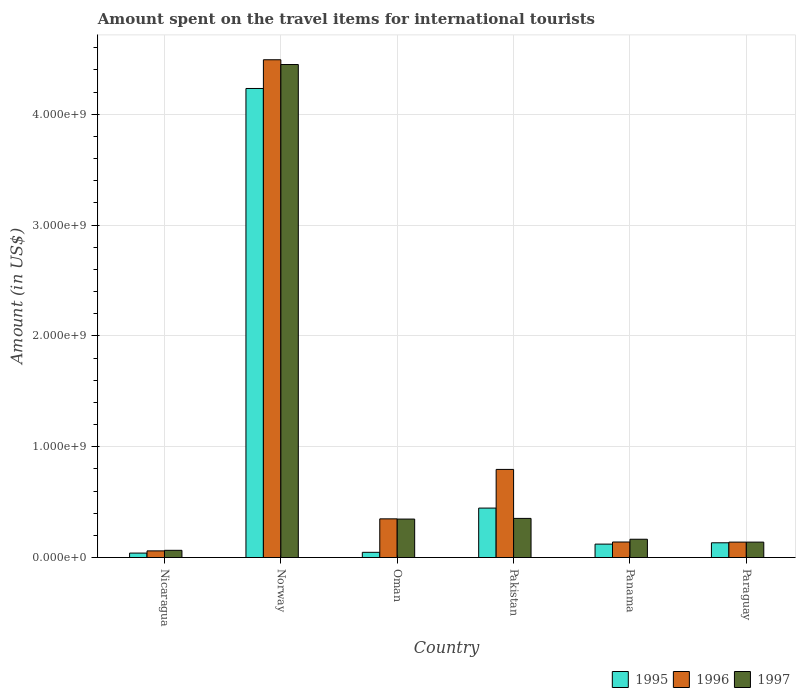How many different coloured bars are there?
Your answer should be very brief. 3. How many groups of bars are there?
Your response must be concise. 6. Are the number of bars per tick equal to the number of legend labels?
Ensure brevity in your answer.  Yes. How many bars are there on the 1st tick from the left?
Your answer should be compact. 3. How many bars are there on the 3rd tick from the right?
Your answer should be compact. 3. What is the amount spent on the travel items for international tourists in 1995 in Oman?
Keep it short and to the point. 4.70e+07. Across all countries, what is the maximum amount spent on the travel items for international tourists in 1996?
Keep it short and to the point. 4.49e+09. Across all countries, what is the minimum amount spent on the travel items for international tourists in 1995?
Offer a terse response. 4.00e+07. In which country was the amount spent on the travel items for international tourists in 1996 minimum?
Give a very brief answer. Nicaragua. What is the total amount spent on the travel items for international tourists in 1996 in the graph?
Offer a terse response. 5.97e+09. What is the difference between the amount spent on the travel items for international tourists in 1997 in Panama and that in Paraguay?
Ensure brevity in your answer.  2.60e+07. What is the difference between the amount spent on the travel items for international tourists in 1996 in Oman and the amount spent on the travel items for international tourists in 1995 in Nicaragua?
Provide a short and direct response. 3.09e+08. What is the average amount spent on the travel items for international tourists in 1995 per country?
Your response must be concise. 8.36e+08. What is the difference between the amount spent on the travel items for international tourists of/in 1995 and amount spent on the travel items for international tourists of/in 1996 in Panama?
Your answer should be very brief. -1.90e+07. In how many countries, is the amount spent on the travel items for international tourists in 1997 greater than 1400000000 US$?
Give a very brief answer. 1. What is the ratio of the amount spent on the travel items for international tourists in 1995 in Norway to that in Oman?
Give a very brief answer. 90.04. Is the difference between the amount spent on the travel items for international tourists in 1995 in Pakistan and Panama greater than the difference between the amount spent on the travel items for international tourists in 1996 in Pakistan and Panama?
Make the answer very short. No. What is the difference between the highest and the second highest amount spent on the travel items for international tourists in 1995?
Give a very brief answer. 4.10e+09. What is the difference between the highest and the lowest amount spent on the travel items for international tourists in 1996?
Offer a very short reply. 4.43e+09. In how many countries, is the amount spent on the travel items for international tourists in 1996 greater than the average amount spent on the travel items for international tourists in 1996 taken over all countries?
Make the answer very short. 1. Is the sum of the amount spent on the travel items for international tourists in 1997 in Oman and Pakistan greater than the maximum amount spent on the travel items for international tourists in 1995 across all countries?
Ensure brevity in your answer.  No. What does the 3rd bar from the right in Panama represents?
Offer a terse response. 1995. Is it the case that in every country, the sum of the amount spent on the travel items for international tourists in 1996 and amount spent on the travel items for international tourists in 1997 is greater than the amount spent on the travel items for international tourists in 1995?
Provide a short and direct response. Yes. How many countries are there in the graph?
Offer a terse response. 6. What is the difference between two consecutive major ticks on the Y-axis?
Give a very brief answer. 1.00e+09. Does the graph contain any zero values?
Your answer should be very brief. No. Where does the legend appear in the graph?
Offer a terse response. Bottom right. What is the title of the graph?
Your response must be concise. Amount spent on the travel items for international tourists. What is the label or title of the X-axis?
Provide a succinct answer. Country. What is the Amount (in US$) of 1995 in Nicaragua?
Provide a short and direct response. 4.00e+07. What is the Amount (in US$) in 1996 in Nicaragua?
Keep it short and to the point. 6.00e+07. What is the Amount (in US$) in 1997 in Nicaragua?
Provide a succinct answer. 6.50e+07. What is the Amount (in US$) of 1995 in Norway?
Give a very brief answer. 4.23e+09. What is the Amount (in US$) in 1996 in Norway?
Provide a succinct answer. 4.49e+09. What is the Amount (in US$) of 1997 in Norway?
Your answer should be very brief. 4.45e+09. What is the Amount (in US$) in 1995 in Oman?
Ensure brevity in your answer.  4.70e+07. What is the Amount (in US$) in 1996 in Oman?
Provide a short and direct response. 3.49e+08. What is the Amount (in US$) of 1997 in Oman?
Offer a very short reply. 3.47e+08. What is the Amount (in US$) of 1995 in Pakistan?
Ensure brevity in your answer.  4.46e+08. What is the Amount (in US$) of 1996 in Pakistan?
Your response must be concise. 7.95e+08. What is the Amount (in US$) of 1997 in Pakistan?
Provide a short and direct response. 3.53e+08. What is the Amount (in US$) of 1995 in Panama?
Your answer should be very brief. 1.21e+08. What is the Amount (in US$) of 1996 in Panama?
Make the answer very short. 1.40e+08. What is the Amount (in US$) in 1997 in Panama?
Keep it short and to the point. 1.65e+08. What is the Amount (in US$) in 1995 in Paraguay?
Provide a succinct answer. 1.33e+08. What is the Amount (in US$) in 1996 in Paraguay?
Provide a succinct answer. 1.39e+08. What is the Amount (in US$) of 1997 in Paraguay?
Your answer should be compact. 1.39e+08. Across all countries, what is the maximum Amount (in US$) of 1995?
Provide a succinct answer. 4.23e+09. Across all countries, what is the maximum Amount (in US$) in 1996?
Give a very brief answer. 4.49e+09. Across all countries, what is the maximum Amount (in US$) in 1997?
Provide a succinct answer. 4.45e+09. Across all countries, what is the minimum Amount (in US$) in 1995?
Your answer should be compact. 4.00e+07. Across all countries, what is the minimum Amount (in US$) of 1996?
Give a very brief answer. 6.00e+07. Across all countries, what is the minimum Amount (in US$) in 1997?
Ensure brevity in your answer.  6.50e+07. What is the total Amount (in US$) of 1995 in the graph?
Give a very brief answer. 5.02e+09. What is the total Amount (in US$) in 1996 in the graph?
Your answer should be very brief. 5.97e+09. What is the total Amount (in US$) in 1997 in the graph?
Give a very brief answer. 5.52e+09. What is the difference between the Amount (in US$) in 1995 in Nicaragua and that in Norway?
Your response must be concise. -4.19e+09. What is the difference between the Amount (in US$) of 1996 in Nicaragua and that in Norway?
Provide a succinct answer. -4.43e+09. What is the difference between the Amount (in US$) in 1997 in Nicaragua and that in Norway?
Your response must be concise. -4.38e+09. What is the difference between the Amount (in US$) in 1995 in Nicaragua and that in Oman?
Offer a terse response. -7.00e+06. What is the difference between the Amount (in US$) in 1996 in Nicaragua and that in Oman?
Offer a very short reply. -2.89e+08. What is the difference between the Amount (in US$) of 1997 in Nicaragua and that in Oman?
Your answer should be compact. -2.82e+08. What is the difference between the Amount (in US$) of 1995 in Nicaragua and that in Pakistan?
Offer a terse response. -4.06e+08. What is the difference between the Amount (in US$) of 1996 in Nicaragua and that in Pakistan?
Offer a terse response. -7.35e+08. What is the difference between the Amount (in US$) in 1997 in Nicaragua and that in Pakistan?
Give a very brief answer. -2.88e+08. What is the difference between the Amount (in US$) in 1995 in Nicaragua and that in Panama?
Your answer should be compact. -8.10e+07. What is the difference between the Amount (in US$) in 1996 in Nicaragua and that in Panama?
Provide a succinct answer. -8.00e+07. What is the difference between the Amount (in US$) in 1997 in Nicaragua and that in Panama?
Offer a very short reply. -1.00e+08. What is the difference between the Amount (in US$) of 1995 in Nicaragua and that in Paraguay?
Give a very brief answer. -9.30e+07. What is the difference between the Amount (in US$) of 1996 in Nicaragua and that in Paraguay?
Make the answer very short. -7.90e+07. What is the difference between the Amount (in US$) of 1997 in Nicaragua and that in Paraguay?
Provide a succinct answer. -7.40e+07. What is the difference between the Amount (in US$) in 1995 in Norway and that in Oman?
Offer a very short reply. 4.18e+09. What is the difference between the Amount (in US$) of 1996 in Norway and that in Oman?
Make the answer very short. 4.14e+09. What is the difference between the Amount (in US$) of 1997 in Norway and that in Oman?
Make the answer very short. 4.10e+09. What is the difference between the Amount (in US$) in 1995 in Norway and that in Pakistan?
Your answer should be very brief. 3.79e+09. What is the difference between the Amount (in US$) in 1996 in Norway and that in Pakistan?
Offer a very short reply. 3.70e+09. What is the difference between the Amount (in US$) of 1997 in Norway and that in Pakistan?
Offer a terse response. 4.10e+09. What is the difference between the Amount (in US$) in 1995 in Norway and that in Panama?
Keep it short and to the point. 4.11e+09. What is the difference between the Amount (in US$) of 1996 in Norway and that in Panama?
Offer a very short reply. 4.35e+09. What is the difference between the Amount (in US$) of 1997 in Norway and that in Panama?
Offer a terse response. 4.28e+09. What is the difference between the Amount (in US$) in 1995 in Norway and that in Paraguay?
Offer a very short reply. 4.10e+09. What is the difference between the Amount (in US$) in 1996 in Norway and that in Paraguay?
Give a very brief answer. 4.35e+09. What is the difference between the Amount (in US$) of 1997 in Norway and that in Paraguay?
Give a very brief answer. 4.31e+09. What is the difference between the Amount (in US$) of 1995 in Oman and that in Pakistan?
Provide a succinct answer. -3.99e+08. What is the difference between the Amount (in US$) of 1996 in Oman and that in Pakistan?
Your answer should be compact. -4.46e+08. What is the difference between the Amount (in US$) in 1997 in Oman and that in Pakistan?
Offer a very short reply. -6.00e+06. What is the difference between the Amount (in US$) of 1995 in Oman and that in Panama?
Keep it short and to the point. -7.40e+07. What is the difference between the Amount (in US$) of 1996 in Oman and that in Panama?
Provide a succinct answer. 2.09e+08. What is the difference between the Amount (in US$) in 1997 in Oman and that in Panama?
Ensure brevity in your answer.  1.82e+08. What is the difference between the Amount (in US$) in 1995 in Oman and that in Paraguay?
Offer a terse response. -8.60e+07. What is the difference between the Amount (in US$) of 1996 in Oman and that in Paraguay?
Make the answer very short. 2.10e+08. What is the difference between the Amount (in US$) of 1997 in Oman and that in Paraguay?
Your answer should be very brief. 2.08e+08. What is the difference between the Amount (in US$) in 1995 in Pakistan and that in Panama?
Offer a terse response. 3.25e+08. What is the difference between the Amount (in US$) of 1996 in Pakistan and that in Panama?
Your response must be concise. 6.55e+08. What is the difference between the Amount (in US$) of 1997 in Pakistan and that in Panama?
Provide a succinct answer. 1.88e+08. What is the difference between the Amount (in US$) in 1995 in Pakistan and that in Paraguay?
Your answer should be very brief. 3.13e+08. What is the difference between the Amount (in US$) of 1996 in Pakistan and that in Paraguay?
Provide a succinct answer. 6.56e+08. What is the difference between the Amount (in US$) of 1997 in Pakistan and that in Paraguay?
Your response must be concise. 2.14e+08. What is the difference between the Amount (in US$) of 1995 in Panama and that in Paraguay?
Your answer should be compact. -1.20e+07. What is the difference between the Amount (in US$) of 1997 in Panama and that in Paraguay?
Make the answer very short. 2.60e+07. What is the difference between the Amount (in US$) in 1995 in Nicaragua and the Amount (in US$) in 1996 in Norway?
Your response must be concise. -4.45e+09. What is the difference between the Amount (in US$) in 1995 in Nicaragua and the Amount (in US$) in 1997 in Norway?
Your response must be concise. -4.41e+09. What is the difference between the Amount (in US$) in 1996 in Nicaragua and the Amount (in US$) in 1997 in Norway?
Your answer should be compact. -4.39e+09. What is the difference between the Amount (in US$) in 1995 in Nicaragua and the Amount (in US$) in 1996 in Oman?
Offer a terse response. -3.09e+08. What is the difference between the Amount (in US$) of 1995 in Nicaragua and the Amount (in US$) of 1997 in Oman?
Provide a short and direct response. -3.07e+08. What is the difference between the Amount (in US$) in 1996 in Nicaragua and the Amount (in US$) in 1997 in Oman?
Provide a short and direct response. -2.87e+08. What is the difference between the Amount (in US$) in 1995 in Nicaragua and the Amount (in US$) in 1996 in Pakistan?
Provide a succinct answer. -7.55e+08. What is the difference between the Amount (in US$) in 1995 in Nicaragua and the Amount (in US$) in 1997 in Pakistan?
Your answer should be very brief. -3.13e+08. What is the difference between the Amount (in US$) of 1996 in Nicaragua and the Amount (in US$) of 1997 in Pakistan?
Keep it short and to the point. -2.93e+08. What is the difference between the Amount (in US$) of 1995 in Nicaragua and the Amount (in US$) of 1996 in Panama?
Keep it short and to the point. -1.00e+08. What is the difference between the Amount (in US$) of 1995 in Nicaragua and the Amount (in US$) of 1997 in Panama?
Provide a succinct answer. -1.25e+08. What is the difference between the Amount (in US$) of 1996 in Nicaragua and the Amount (in US$) of 1997 in Panama?
Your answer should be compact. -1.05e+08. What is the difference between the Amount (in US$) in 1995 in Nicaragua and the Amount (in US$) in 1996 in Paraguay?
Offer a terse response. -9.90e+07. What is the difference between the Amount (in US$) of 1995 in Nicaragua and the Amount (in US$) of 1997 in Paraguay?
Provide a short and direct response. -9.90e+07. What is the difference between the Amount (in US$) of 1996 in Nicaragua and the Amount (in US$) of 1997 in Paraguay?
Provide a short and direct response. -7.90e+07. What is the difference between the Amount (in US$) of 1995 in Norway and the Amount (in US$) of 1996 in Oman?
Your answer should be compact. 3.88e+09. What is the difference between the Amount (in US$) in 1995 in Norway and the Amount (in US$) in 1997 in Oman?
Keep it short and to the point. 3.88e+09. What is the difference between the Amount (in US$) of 1996 in Norway and the Amount (in US$) of 1997 in Oman?
Give a very brief answer. 4.14e+09. What is the difference between the Amount (in US$) of 1995 in Norway and the Amount (in US$) of 1996 in Pakistan?
Provide a short and direct response. 3.44e+09. What is the difference between the Amount (in US$) in 1995 in Norway and the Amount (in US$) in 1997 in Pakistan?
Your response must be concise. 3.88e+09. What is the difference between the Amount (in US$) of 1996 in Norway and the Amount (in US$) of 1997 in Pakistan?
Ensure brevity in your answer.  4.14e+09. What is the difference between the Amount (in US$) of 1995 in Norway and the Amount (in US$) of 1996 in Panama?
Keep it short and to the point. 4.09e+09. What is the difference between the Amount (in US$) of 1995 in Norway and the Amount (in US$) of 1997 in Panama?
Your answer should be very brief. 4.07e+09. What is the difference between the Amount (in US$) in 1996 in Norway and the Amount (in US$) in 1997 in Panama?
Your response must be concise. 4.33e+09. What is the difference between the Amount (in US$) in 1995 in Norway and the Amount (in US$) in 1996 in Paraguay?
Give a very brief answer. 4.09e+09. What is the difference between the Amount (in US$) in 1995 in Norway and the Amount (in US$) in 1997 in Paraguay?
Keep it short and to the point. 4.09e+09. What is the difference between the Amount (in US$) of 1996 in Norway and the Amount (in US$) of 1997 in Paraguay?
Make the answer very short. 4.35e+09. What is the difference between the Amount (in US$) of 1995 in Oman and the Amount (in US$) of 1996 in Pakistan?
Your answer should be very brief. -7.48e+08. What is the difference between the Amount (in US$) of 1995 in Oman and the Amount (in US$) of 1997 in Pakistan?
Offer a terse response. -3.06e+08. What is the difference between the Amount (in US$) in 1995 in Oman and the Amount (in US$) in 1996 in Panama?
Provide a short and direct response. -9.30e+07. What is the difference between the Amount (in US$) of 1995 in Oman and the Amount (in US$) of 1997 in Panama?
Offer a terse response. -1.18e+08. What is the difference between the Amount (in US$) in 1996 in Oman and the Amount (in US$) in 1997 in Panama?
Provide a short and direct response. 1.84e+08. What is the difference between the Amount (in US$) of 1995 in Oman and the Amount (in US$) of 1996 in Paraguay?
Give a very brief answer. -9.20e+07. What is the difference between the Amount (in US$) of 1995 in Oman and the Amount (in US$) of 1997 in Paraguay?
Ensure brevity in your answer.  -9.20e+07. What is the difference between the Amount (in US$) in 1996 in Oman and the Amount (in US$) in 1997 in Paraguay?
Make the answer very short. 2.10e+08. What is the difference between the Amount (in US$) in 1995 in Pakistan and the Amount (in US$) in 1996 in Panama?
Give a very brief answer. 3.06e+08. What is the difference between the Amount (in US$) in 1995 in Pakistan and the Amount (in US$) in 1997 in Panama?
Your answer should be compact. 2.81e+08. What is the difference between the Amount (in US$) of 1996 in Pakistan and the Amount (in US$) of 1997 in Panama?
Provide a short and direct response. 6.30e+08. What is the difference between the Amount (in US$) in 1995 in Pakistan and the Amount (in US$) in 1996 in Paraguay?
Offer a terse response. 3.07e+08. What is the difference between the Amount (in US$) in 1995 in Pakistan and the Amount (in US$) in 1997 in Paraguay?
Offer a terse response. 3.07e+08. What is the difference between the Amount (in US$) of 1996 in Pakistan and the Amount (in US$) of 1997 in Paraguay?
Keep it short and to the point. 6.56e+08. What is the difference between the Amount (in US$) in 1995 in Panama and the Amount (in US$) in 1996 in Paraguay?
Keep it short and to the point. -1.80e+07. What is the difference between the Amount (in US$) of 1995 in Panama and the Amount (in US$) of 1997 in Paraguay?
Keep it short and to the point. -1.80e+07. What is the difference between the Amount (in US$) of 1996 in Panama and the Amount (in US$) of 1997 in Paraguay?
Keep it short and to the point. 1.00e+06. What is the average Amount (in US$) in 1995 per country?
Ensure brevity in your answer.  8.36e+08. What is the average Amount (in US$) of 1996 per country?
Ensure brevity in your answer.  9.96e+08. What is the average Amount (in US$) in 1997 per country?
Offer a terse response. 9.20e+08. What is the difference between the Amount (in US$) of 1995 and Amount (in US$) of 1996 in Nicaragua?
Your response must be concise. -2.00e+07. What is the difference between the Amount (in US$) in 1995 and Amount (in US$) in 1997 in Nicaragua?
Your answer should be compact. -2.50e+07. What is the difference between the Amount (in US$) in 1996 and Amount (in US$) in 1997 in Nicaragua?
Give a very brief answer. -5.00e+06. What is the difference between the Amount (in US$) of 1995 and Amount (in US$) of 1996 in Norway?
Provide a succinct answer. -2.59e+08. What is the difference between the Amount (in US$) in 1995 and Amount (in US$) in 1997 in Norway?
Offer a very short reply. -2.16e+08. What is the difference between the Amount (in US$) of 1996 and Amount (in US$) of 1997 in Norway?
Ensure brevity in your answer.  4.30e+07. What is the difference between the Amount (in US$) of 1995 and Amount (in US$) of 1996 in Oman?
Your answer should be very brief. -3.02e+08. What is the difference between the Amount (in US$) of 1995 and Amount (in US$) of 1997 in Oman?
Your answer should be very brief. -3.00e+08. What is the difference between the Amount (in US$) of 1996 and Amount (in US$) of 1997 in Oman?
Offer a very short reply. 2.00e+06. What is the difference between the Amount (in US$) of 1995 and Amount (in US$) of 1996 in Pakistan?
Ensure brevity in your answer.  -3.49e+08. What is the difference between the Amount (in US$) of 1995 and Amount (in US$) of 1997 in Pakistan?
Your response must be concise. 9.30e+07. What is the difference between the Amount (in US$) of 1996 and Amount (in US$) of 1997 in Pakistan?
Offer a very short reply. 4.42e+08. What is the difference between the Amount (in US$) in 1995 and Amount (in US$) in 1996 in Panama?
Offer a very short reply. -1.90e+07. What is the difference between the Amount (in US$) of 1995 and Amount (in US$) of 1997 in Panama?
Provide a short and direct response. -4.40e+07. What is the difference between the Amount (in US$) of 1996 and Amount (in US$) of 1997 in Panama?
Your answer should be compact. -2.50e+07. What is the difference between the Amount (in US$) of 1995 and Amount (in US$) of 1996 in Paraguay?
Make the answer very short. -6.00e+06. What is the difference between the Amount (in US$) in 1995 and Amount (in US$) in 1997 in Paraguay?
Your answer should be very brief. -6.00e+06. What is the ratio of the Amount (in US$) in 1995 in Nicaragua to that in Norway?
Keep it short and to the point. 0.01. What is the ratio of the Amount (in US$) of 1996 in Nicaragua to that in Norway?
Provide a short and direct response. 0.01. What is the ratio of the Amount (in US$) of 1997 in Nicaragua to that in Norway?
Your response must be concise. 0.01. What is the ratio of the Amount (in US$) of 1995 in Nicaragua to that in Oman?
Provide a short and direct response. 0.85. What is the ratio of the Amount (in US$) of 1996 in Nicaragua to that in Oman?
Offer a very short reply. 0.17. What is the ratio of the Amount (in US$) of 1997 in Nicaragua to that in Oman?
Make the answer very short. 0.19. What is the ratio of the Amount (in US$) of 1995 in Nicaragua to that in Pakistan?
Your answer should be very brief. 0.09. What is the ratio of the Amount (in US$) in 1996 in Nicaragua to that in Pakistan?
Ensure brevity in your answer.  0.08. What is the ratio of the Amount (in US$) in 1997 in Nicaragua to that in Pakistan?
Your response must be concise. 0.18. What is the ratio of the Amount (in US$) of 1995 in Nicaragua to that in Panama?
Give a very brief answer. 0.33. What is the ratio of the Amount (in US$) in 1996 in Nicaragua to that in Panama?
Offer a terse response. 0.43. What is the ratio of the Amount (in US$) of 1997 in Nicaragua to that in Panama?
Make the answer very short. 0.39. What is the ratio of the Amount (in US$) in 1995 in Nicaragua to that in Paraguay?
Your answer should be compact. 0.3. What is the ratio of the Amount (in US$) of 1996 in Nicaragua to that in Paraguay?
Your answer should be compact. 0.43. What is the ratio of the Amount (in US$) of 1997 in Nicaragua to that in Paraguay?
Your response must be concise. 0.47. What is the ratio of the Amount (in US$) in 1995 in Norway to that in Oman?
Offer a very short reply. 90.04. What is the ratio of the Amount (in US$) in 1996 in Norway to that in Oman?
Offer a terse response. 12.87. What is the ratio of the Amount (in US$) of 1997 in Norway to that in Oman?
Keep it short and to the point. 12.82. What is the ratio of the Amount (in US$) in 1995 in Norway to that in Pakistan?
Provide a short and direct response. 9.49. What is the ratio of the Amount (in US$) in 1996 in Norway to that in Pakistan?
Give a very brief answer. 5.65. What is the ratio of the Amount (in US$) in 1997 in Norway to that in Pakistan?
Your response must be concise. 12.6. What is the ratio of the Amount (in US$) of 1995 in Norway to that in Panama?
Your answer should be compact. 34.98. What is the ratio of the Amount (in US$) in 1996 in Norway to that in Panama?
Your answer should be very brief. 32.08. What is the ratio of the Amount (in US$) of 1997 in Norway to that in Panama?
Offer a very short reply. 26.96. What is the ratio of the Amount (in US$) in 1995 in Norway to that in Paraguay?
Offer a very short reply. 31.82. What is the ratio of the Amount (in US$) in 1996 in Norway to that in Paraguay?
Offer a very short reply. 32.31. What is the ratio of the Amount (in US$) of 1997 in Norway to that in Paraguay?
Your answer should be compact. 32. What is the ratio of the Amount (in US$) in 1995 in Oman to that in Pakistan?
Offer a terse response. 0.11. What is the ratio of the Amount (in US$) in 1996 in Oman to that in Pakistan?
Your answer should be very brief. 0.44. What is the ratio of the Amount (in US$) of 1995 in Oman to that in Panama?
Offer a very short reply. 0.39. What is the ratio of the Amount (in US$) in 1996 in Oman to that in Panama?
Make the answer very short. 2.49. What is the ratio of the Amount (in US$) of 1997 in Oman to that in Panama?
Ensure brevity in your answer.  2.1. What is the ratio of the Amount (in US$) of 1995 in Oman to that in Paraguay?
Keep it short and to the point. 0.35. What is the ratio of the Amount (in US$) of 1996 in Oman to that in Paraguay?
Provide a short and direct response. 2.51. What is the ratio of the Amount (in US$) in 1997 in Oman to that in Paraguay?
Offer a very short reply. 2.5. What is the ratio of the Amount (in US$) in 1995 in Pakistan to that in Panama?
Provide a succinct answer. 3.69. What is the ratio of the Amount (in US$) of 1996 in Pakistan to that in Panama?
Make the answer very short. 5.68. What is the ratio of the Amount (in US$) in 1997 in Pakistan to that in Panama?
Provide a succinct answer. 2.14. What is the ratio of the Amount (in US$) in 1995 in Pakistan to that in Paraguay?
Provide a succinct answer. 3.35. What is the ratio of the Amount (in US$) of 1996 in Pakistan to that in Paraguay?
Give a very brief answer. 5.72. What is the ratio of the Amount (in US$) of 1997 in Pakistan to that in Paraguay?
Make the answer very short. 2.54. What is the ratio of the Amount (in US$) in 1995 in Panama to that in Paraguay?
Make the answer very short. 0.91. What is the ratio of the Amount (in US$) in 1996 in Panama to that in Paraguay?
Your answer should be very brief. 1.01. What is the ratio of the Amount (in US$) of 1997 in Panama to that in Paraguay?
Offer a terse response. 1.19. What is the difference between the highest and the second highest Amount (in US$) in 1995?
Give a very brief answer. 3.79e+09. What is the difference between the highest and the second highest Amount (in US$) in 1996?
Ensure brevity in your answer.  3.70e+09. What is the difference between the highest and the second highest Amount (in US$) of 1997?
Offer a terse response. 4.10e+09. What is the difference between the highest and the lowest Amount (in US$) of 1995?
Your response must be concise. 4.19e+09. What is the difference between the highest and the lowest Amount (in US$) of 1996?
Make the answer very short. 4.43e+09. What is the difference between the highest and the lowest Amount (in US$) in 1997?
Provide a short and direct response. 4.38e+09. 